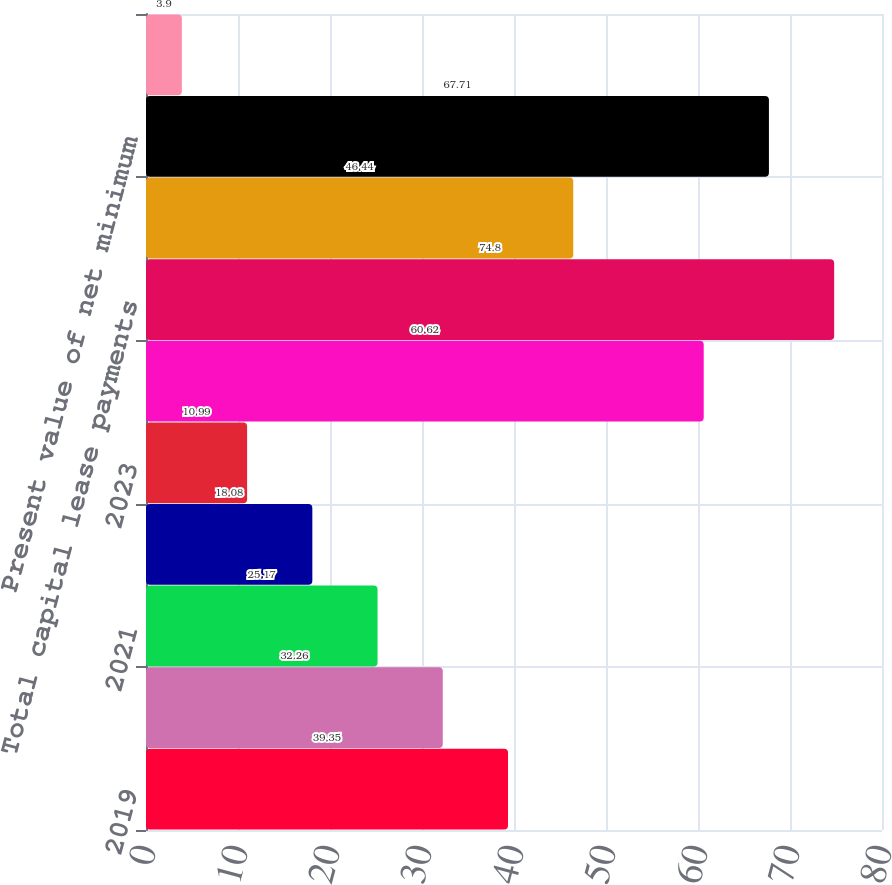Convert chart. <chart><loc_0><loc_0><loc_500><loc_500><bar_chart><fcel>2019<fcel>2020<fcel>2021<fcel>2022<fcel>2023<fcel>After 2023<fcel>Total capital lease payments<fcel>Amounts representing imputed<fcel>Present value of net minimum<fcel>Less current portion<nl><fcel>39.35<fcel>32.26<fcel>25.17<fcel>18.08<fcel>10.99<fcel>60.62<fcel>74.8<fcel>46.44<fcel>67.71<fcel>3.9<nl></chart> 